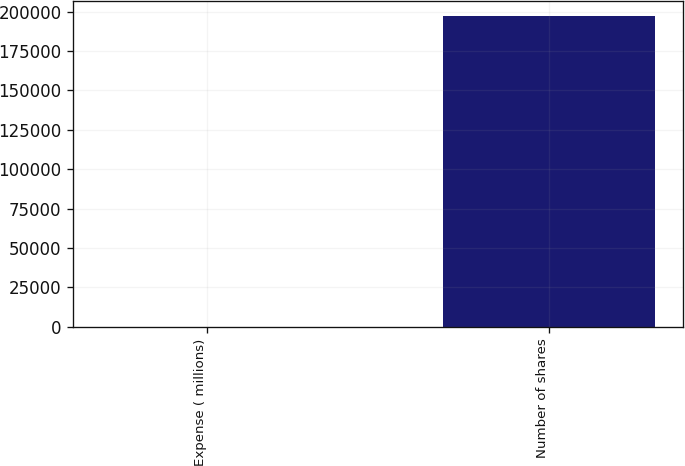<chart> <loc_0><loc_0><loc_500><loc_500><bar_chart><fcel>Expense ( millions)<fcel>Number of shares<nl><fcel>17.1<fcel>197052<nl></chart> 